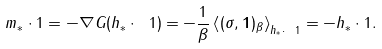<formula> <loc_0><loc_0><loc_500><loc_500>m _ { * } \cdot 1 = - \nabla G ( h _ { * } \cdot \ 1 ) = - \frac { 1 } { \beta } \left \langle ( \sigma , \mathbf 1 ) _ { \beta } \right \rangle _ { h _ { * } \cdot \ 1 } = - h _ { * } \cdot 1 .</formula> 